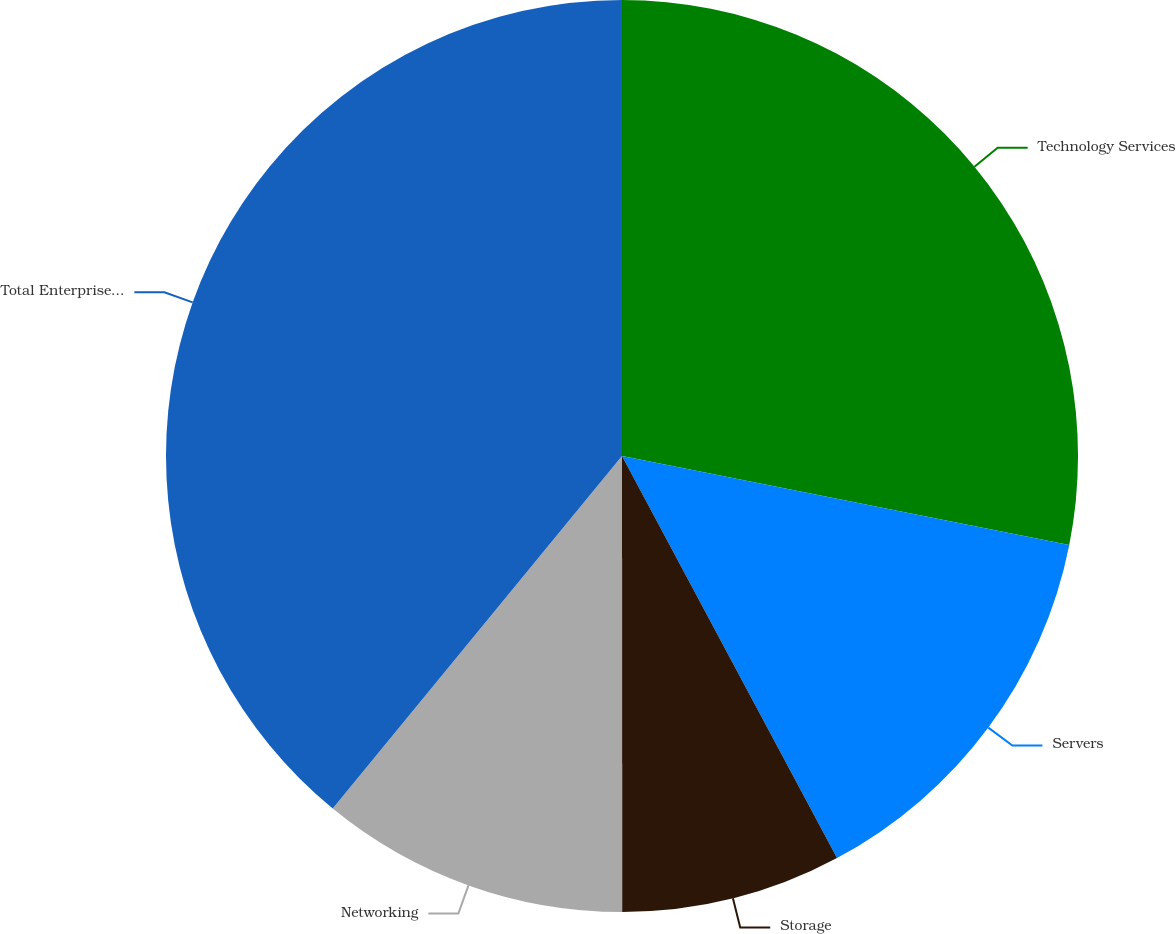<chart> <loc_0><loc_0><loc_500><loc_500><pie_chart><fcel>Technology Services<fcel>Servers<fcel>Storage<fcel>Networking<fcel>Total Enterprise Group<nl><fcel>28.12%<fcel>14.06%<fcel>7.81%<fcel>10.94%<fcel>39.06%<nl></chart> 